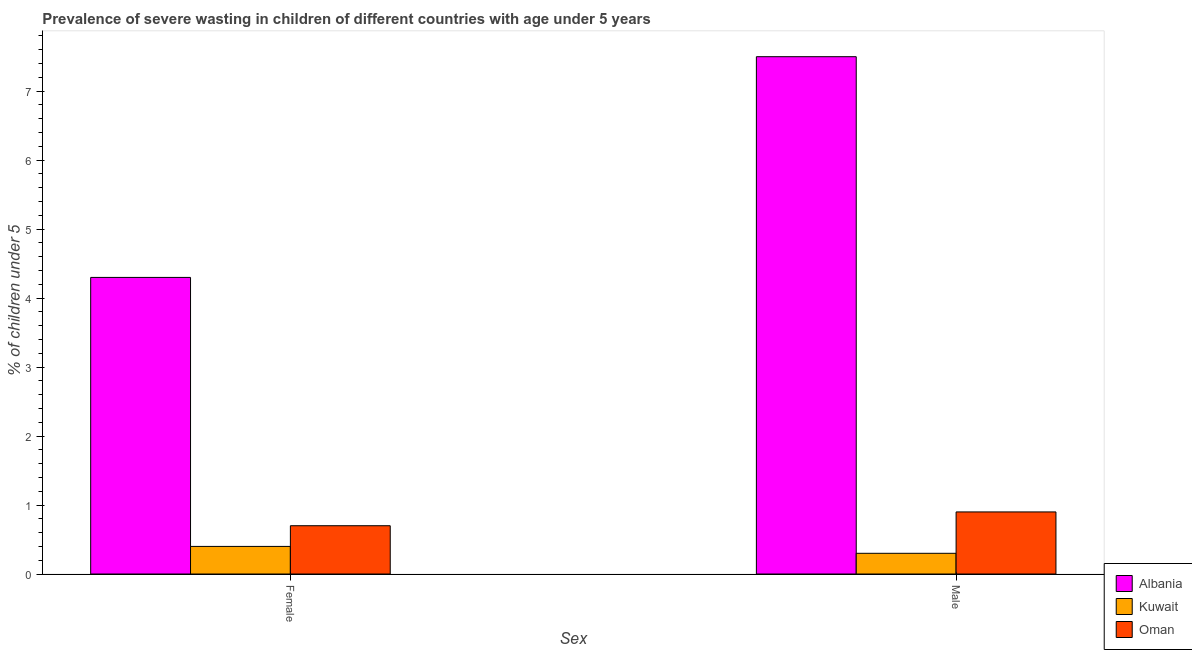How many bars are there on the 1st tick from the left?
Your response must be concise. 3. What is the percentage of undernourished male children in Kuwait?
Make the answer very short. 0.3. Across all countries, what is the minimum percentage of undernourished male children?
Make the answer very short. 0.3. In which country was the percentage of undernourished male children maximum?
Give a very brief answer. Albania. In which country was the percentage of undernourished female children minimum?
Keep it short and to the point. Kuwait. What is the total percentage of undernourished female children in the graph?
Provide a short and direct response. 5.4. What is the difference between the percentage of undernourished female children in Albania and that in Kuwait?
Keep it short and to the point. 3.9. What is the difference between the percentage of undernourished male children in Albania and the percentage of undernourished female children in Oman?
Ensure brevity in your answer.  6.8. What is the average percentage of undernourished male children per country?
Your answer should be compact. 2.9. What is the difference between the percentage of undernourished female children and percentage of undernourished male children in Albania?
Provide a short and direct response. -3.2. What is the ratio of the percentage of undernourished male children in Albania to that in Kuwait?
Ensure brevity in your answer.  25. In how many countries, is the percentage of undernourished female children greater than the average percentage of undernourished female children taken over all countries?
Offer a terse response. 1. What does the 3rd bar from the left in Male represents?
Give a very brief answer. Oman. What does the 2nd bar from the right in Female represents?
Provide a short and direct response. Kuwait. How many bars are there?
Offer a terse response. 6. Are the values on the major ticks of Y-axis written in scientific E-notation?
Your answer should be very brief. No. Does the graph contain grids?
Your answer should be very brief. No. Where does the legend appear in the graph?
Your response must be concise. Bottom right. What is the title of the graph?
Make the answer very short. Prevalence of severe wasting in children of different countries with age under 5 years. Does "Curacao" appear as one of the legend labels in the graph?
Keep it short and to the point. No. What is the label or title of the X-axis?
Provide a short and direct response. Sex. What is the label or title of the Y-axis?
Keep it short and to the point.  % of children under 5. What is the  % of children under 5 in Albania in Female?
Ensure brevity in your answer.  4.3. What is the  % of children under 5 in Kuwait in Female?
Your answer should be very brief. 0.4. What is the  % of children under 5 of Oman in Female?
Make the answer very short. 0.7. What is the  % of children under 5 in Albania in Male?
Offer a terse response. 7.5. What is the  % of children under 5 of Kuwait in Male?
Provide a succinct answer. 0.3. What is the  % of children under 5 in Oman in Male?
Offer a terse response. 0.9. Across all Sex, what is the maximum  % of children under 5 of Kuwait?
Give a very brief answer. 0.4. Across all Sex, what is the maximum  % of children under 5 in Oman?
Provide a succinct answer. 0.9. Across all Sex, what is the minimum  % of children under 5 of Albania?
Provide a short and direct response. 4.3. Across all Sex, what is the minimum  % of children under 5 in Kuwait?
Give a very brief answer. 0.3. Across all Sex, what is the minimum  % of children under 5 in Oman?
Your answer should be very brief. 0.7. What is the total  % of children under 5 in Oman in the graph?
Offer a terse response. 1.6. What is the difference between the  % of children under 5 of Albania in Female and that in Male?
Provide a short and direct response. -3.2. What is the difference between the  % of children under 5 of Albania in Female and the  % of children under 5 of Kuwait in Male?
Give a very brief answer. 4. What is the difference between the  % of children under 5 in Kuwait in Female and the  % of children under 5 in Oman in Male?
Your answer should be very brief. -0.5. What is the difference between the  % of children under 5 of Albania and  % of children under 5 of Kuwait in Female?
Your answer should be very brief. 3.9. What is the difference between the  % of children under 5 in Kuwait and  % of children under 5 in Oman in Female?
Offer a terse response. -0.3. What is the difference between the  % of children under 5 of Albania and  % of children under 5 of Kuwait in Male?
Your answer should be very brief. 7.2. What is the ratio of the  % of children under 5 of Albania in Female to that in Male?
Give a very brief answer. 0.57. What is the ratio of the  % of children under 5 in Kuwait in Female to that in Male?
Your answer should be compact. 1.33. What is the difference between the highest and the lowest  % of children under 5 in Albania?
Give a very brief answer. 3.2. What is the difference between the highest and the lowest  % of children under 5 in Kuwait?
Ensure brevity in your answer.  0.1. What is the difference between the highest and the lowest  % of children under 5 in Oman?
Your response must be concise. 0.2. 